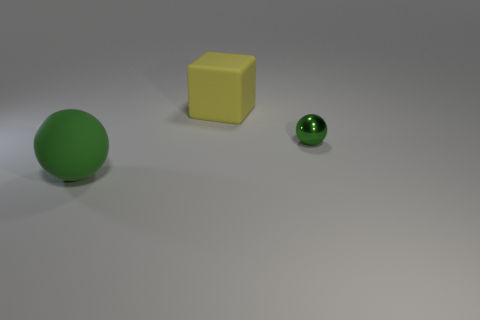Add 2 red metal balls. How many objects exist? 5 Subtract 1 balls. How many balls are left? 1 Subtract 0 blue cylinders. How many objects are left? 3 Subtract all balls. How many objects are left? 1 Subtract all gray balls. Subtract all brown cylinders. How many balls are left? 2 Subtract all large yellow rubber things. Subtract all large cubes. How many objects are left? 1 Add 2 tiny objects. How many tiny objects are left? 3 Add 1 big yellow objects. How many big yellow objects exist? 2 